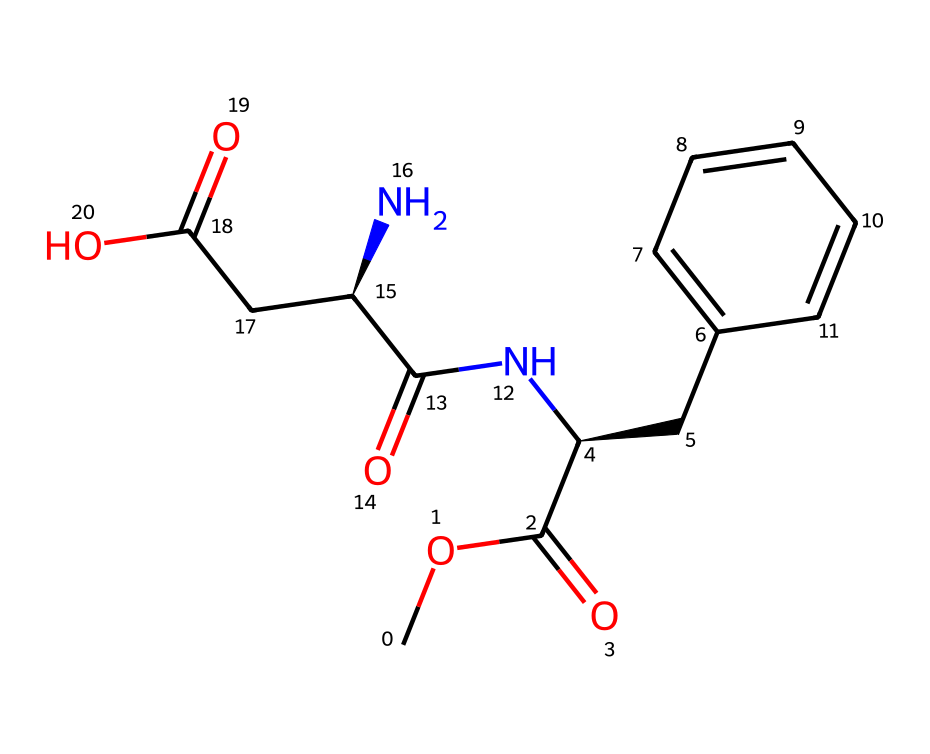What is the molecular formula of aspartame? To determine the molecular formula, count the number of each type of atom in the SMILES representation. The provided SMILES includes multiple Carbon (C), Hydrogen (H), Nitrogen (N), and Oxygen (O) atoms. By tallying, we find the counts: 14 carbons, 18 hydrogens, 2 nitrogens, and 5 oxygens. Therefore, the molecular formula is C14H18N2O5.
Answer: C14H18N2O5 How many chiral centers are present in aspartame? A chiral center is identified by the presence of a carbon atom bonded to four different substituents. By analyzing the structure, there are two carbon atoms in the SMILES that meet this criterion. Thus, aspartame contains two chiral centers.
Answer: 2 What is the significance of the chiral centers in aspartame? The chiral centers in aspartame impart optical activity, meaning the compound can exist in two enantiomeric forms that have different sensory properties, notably sweetness. The specific arrangement of these centers determines the active sweetening form, enhancing its sweetness compared to its non-chiral counterparts.
Answer: optical activity What type of chemical compound is aspartame? Aspartame is classified as a dipeptide, which is a compound formed from two amino acids linked by a peptide bond. In the SMILES, the presence of amide linkages and the arrangement of amino and carboxyl functional groups confirm its classification.
Answer: dipeptide Which functional groups are present in aspartame? Analyzing the structure from the SMILES indicates the presence of several functional groups: an amide due to the presence of -C(=O)N- bonds, carboxylic acids evidenced by -COOH groups, and a methoxy group from -O-CH3. This combination creates various properties influencing its sweet taste.
Answer: amide, carboxylic acid, methoxy How does the structure of aspartame affect its sweetness? The specific arrangement of atoms and the presence of chiral centers contribute to the spatial configuration of aspartame, which binds to sweet taste receptors more effectively than its non-chiral forms. This higher affinity drives its intense sweetness, often estimated to be 200 times sweeter than sucrose.
Answer: higher affinity 